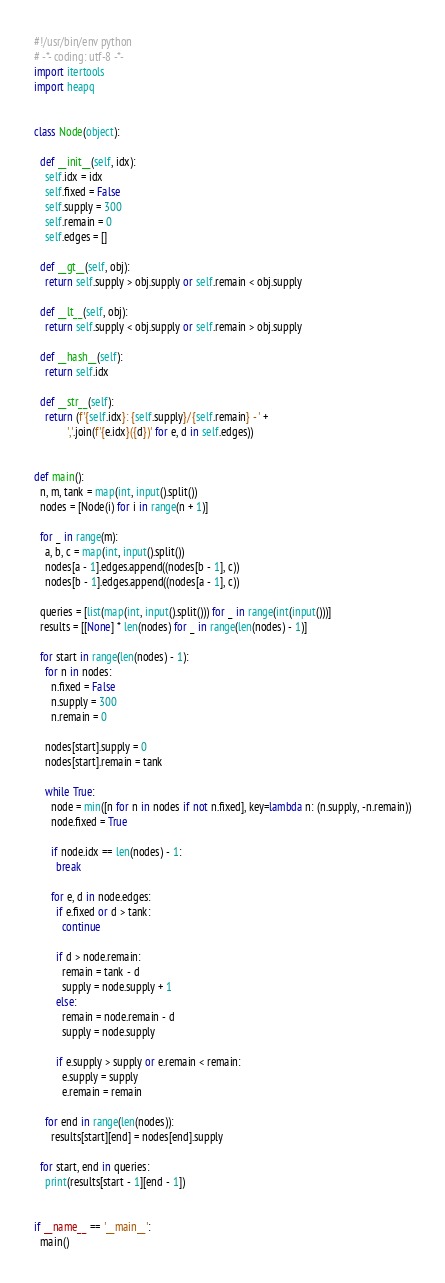Convert code to text. <code><loc_0><loc_0><loc_500><loc_500><_Python_>#!/usr/bin/env python
# -*- coding: utf-8 -*-
import itertools
import heapq


class Node(object):

  def __init__(self, idx):
    self.idx = idx
    self.fixed = False
    self.supply = 300
    self.remain = 0
    self.edges = []

  def __gt__(self, obj):
    return self.supply > obj.supply or self.remain < obj.supply

  def __lt__(self, obj):
    return self.supply < obj.supply or self.remain > obj.supply

  def __hash__(self):
    return self.idx

  def __str__(self):
    return (f'{self.idx}: {self.supply}/{self.remain} - ' +
            ','.join(f'{e.idx}({d})' for e, d in self.edges))


def main():
  n, m, tank = map(int, input().split())
  nodes = [Node(i) for i in range(n + 1)]

  for _ in range(m):
    a, b, c = map(int, input().split())
    nodes[a - 1].edges.append((nodes[b - 1], c))
    nodes[b - 1].edges.append((nodes[a - 1], c))

  queries = [list(map(int, input().split())) for _ in range(int(input()))]
  results = [[None] * len(nodes) for _ in range(len(nodes) - 1)]

  for start in range(len(nodes) - 1):
    for n in nodes:
      n.fixed = False
      n.supply = 300
      n.remain = 0

    nodes[start].supply = 0
    nodes[start].remain = tank

    while True:
      node = min([n for n in nodes if not n.fixed], key=lambda n: (n.supply, -n.remain))
      node.fixed = True

      if node.idx == len(nodes) - 1:
        break

      for e, d in node.edges:
        if e.fixed or d > tank:
          continue

        if d > node.remain:
          remain = tank - d
          supply = node.supply + 1
        else:
          remain = node.remain - d
          supply = node.supply

        if e.supply > supply or e.remain < remain:
          e.supply = supply
          e.remain = remain

    for end in range(len(nodes)):
      results[start][end] = nodes[end].supply

  for start, end in queries:
    print(results[start - 1][end - 1])


if __name__ == '__main__':
  main()

</code> 